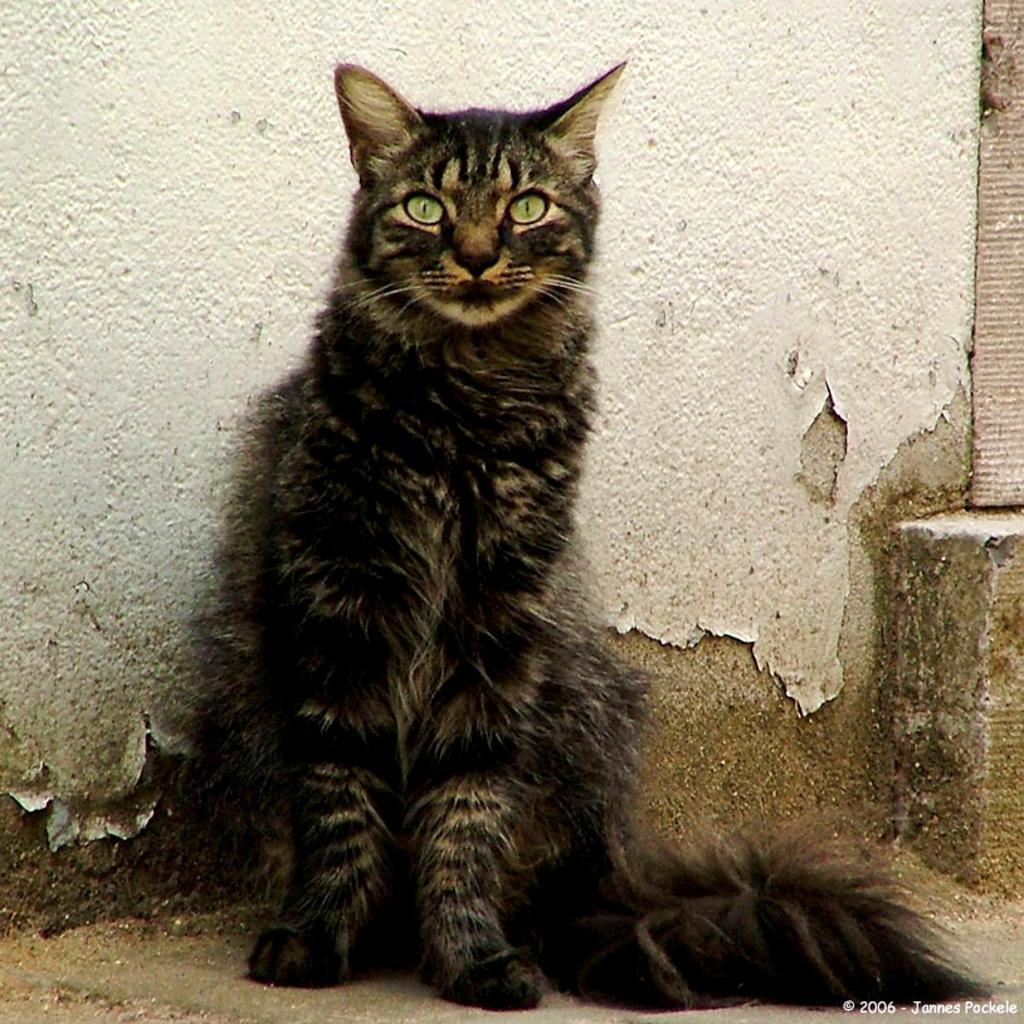Please provide a concise description of this image. In this image in the center there is one cat and in the background there is a wall, at the bottom there is a walkway. 